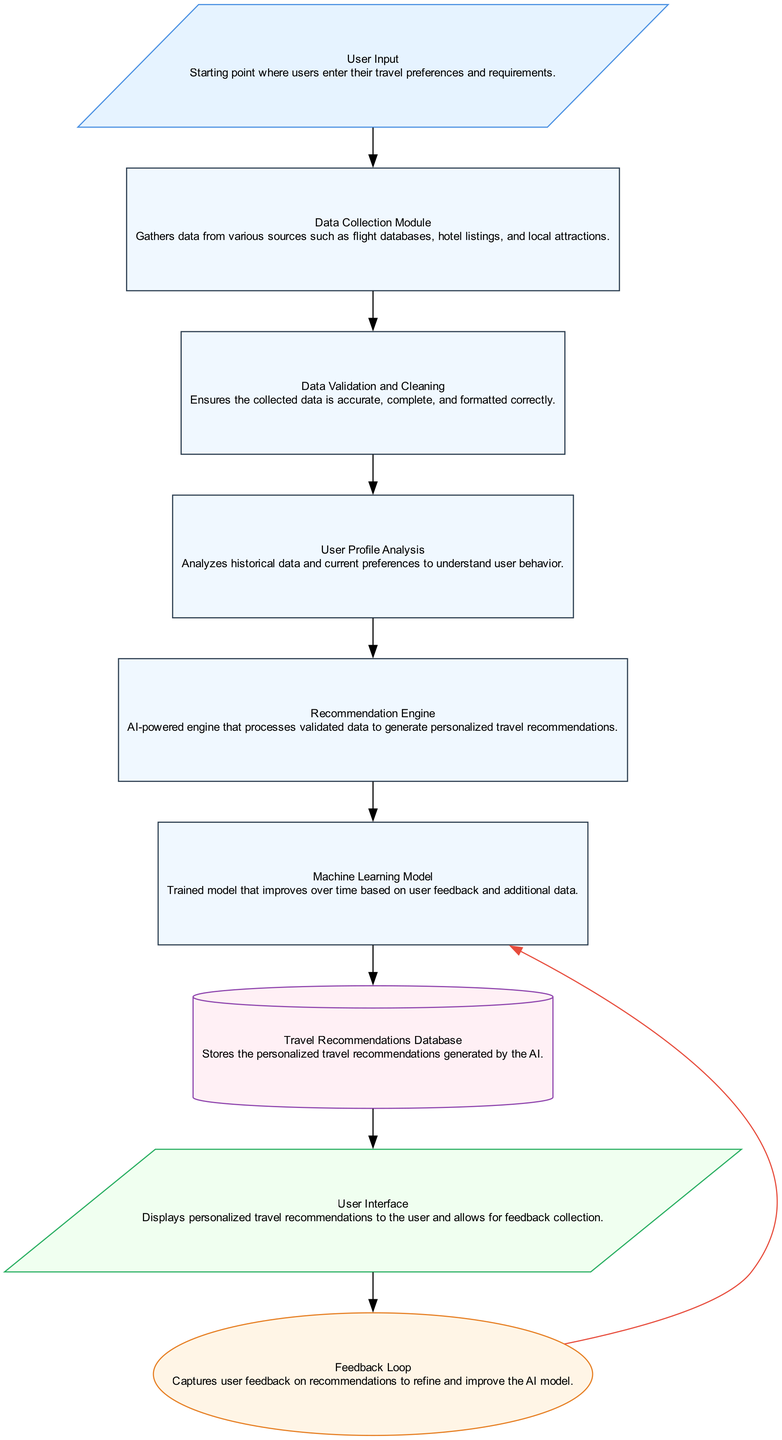What is the starting point of the data pipeline? The starting point of the data pipeline is the "User Input" node, where users enter their travel preferences and requirements.
Answer: User Input How many process nodes are in the diagram? There are 5 process nodes, which are "Data Collection Module," "Data Validation and Cleaning," "User Profile Analysis," "Recommendation Engine," and "Machine Learning Model."
Answer: 5 Which node follows the "Recommendation Engine"? The node that follows the "Recommendation Engine" is the "Machine Learning Model."
Answer: Machine Learning Model What type of feedback mechanism is shown in the diagram? The feedback mechanism shown in the diagram is the "Feedback Loop," which captures user feedback on recommendations to refine and improve the AI model.
Answer: Feedback Loop How does the User Interface relate to the Feedback Loop? The User Interface node connects to the Feedback Loop by capturing user feedback on travel recommendations and sending it to the Machine Learning Model for improvement.
Answer: User Interface to Feedback Loop Which data storage element holds personalized travel recommendations? The "Travel Recommendations Database" stores the personalized travel recommendations that are generated by the AI.
Answer: Travel Recommendations Database What is the final output of the pipeline? The final output of the pipeline is the "User Interface," which displays the personalized travel recommendations to the user.
Answer: User Interface What is the role of the Data Validation and Cleaning node? The "Data Validation and Cleaning" node ensures that the collected data is accurate, complete, and formatted correctly before further processing.
Answer: Ensures accuracy and completeness In what order do the processes operate from user input to recommendations? The order is: User Input → Data Collection Module → Data Validation and Cleaning → User Profile Analysis → Recommendation Engine → Machine Learning Model.
Answer: User Input to Machine Learning Model Which node is responsible for analyzing user behavior? The "User Profile Analysis" node is responsible for analyzing historical data and current preferences to understand user behavior.
Answer: User Profile Analysis 